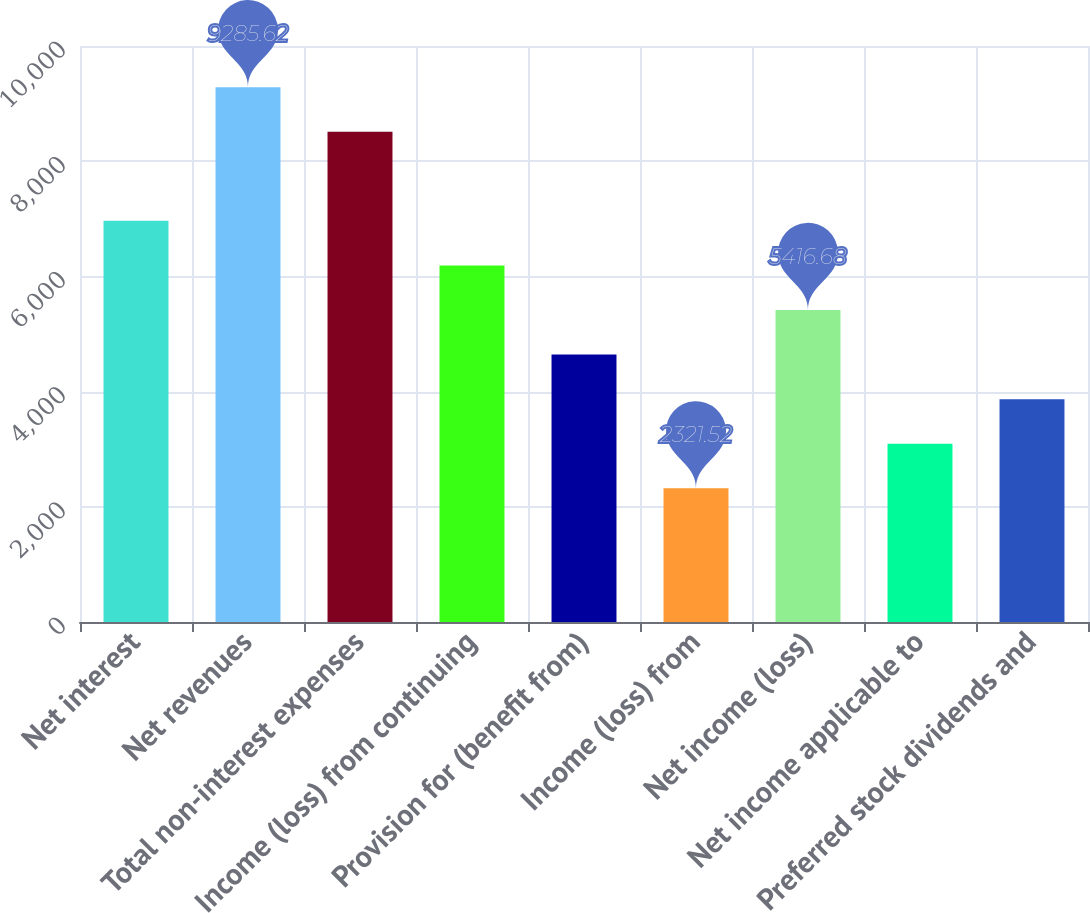Convert chart. <chart><loc_0><loc_0><loc_500><loc_500><bar_chart><fcel>Net interest<fcel>Net revenues<fcel>Total non-interest expenses<fcel>Income (loss) from continuing<fcel>Provision for (benefit from)<fcel>Income (loss) from<fcel>Net income (loss)<fcel>Net income applicable to<fcel>Preferred stock dividends and<nl><fcel>6964.26<fcel>9285.62<fcel>8511.84<fcel>6190.47<fcel>4642.89<fcel>2321.52<fcel>5416.68<fcel>3095.31<fcel>3869.1<nl></chart> 